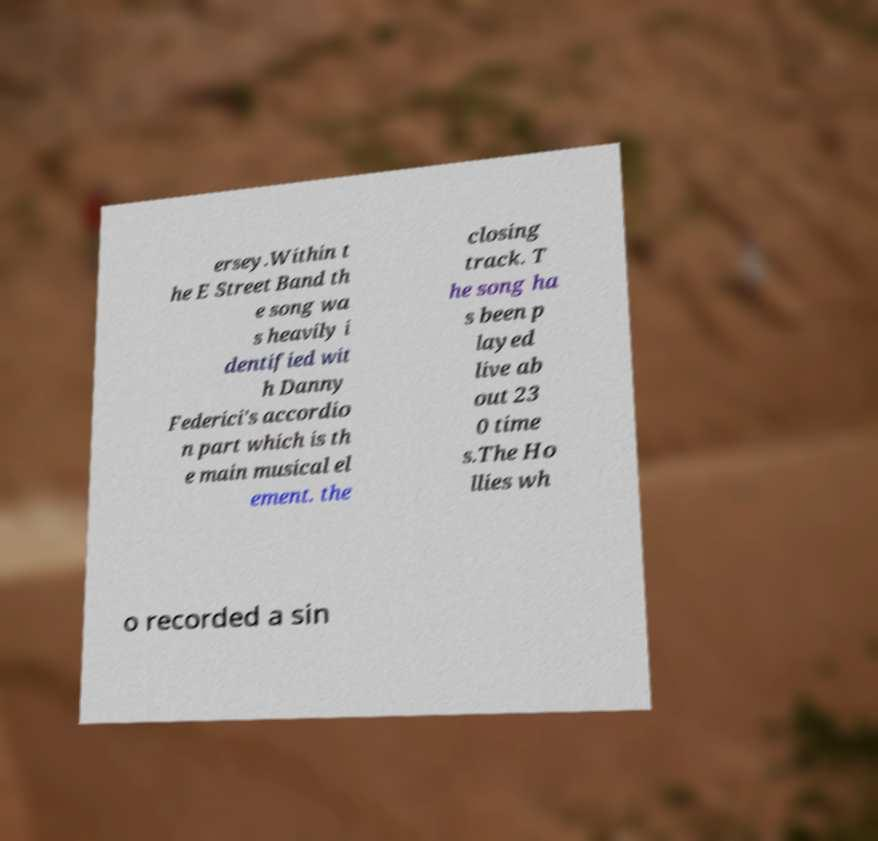Could you extract and type out the text from this image? ersey.Within t he E Street Band th e song wa s heavily i dentified wit h Danny Federici's accordio n part which is th e main musical el ement. the closing track. T he song ha s been p layed live ab out 23 0 time s.The Ho llies wh o recorded a sin 